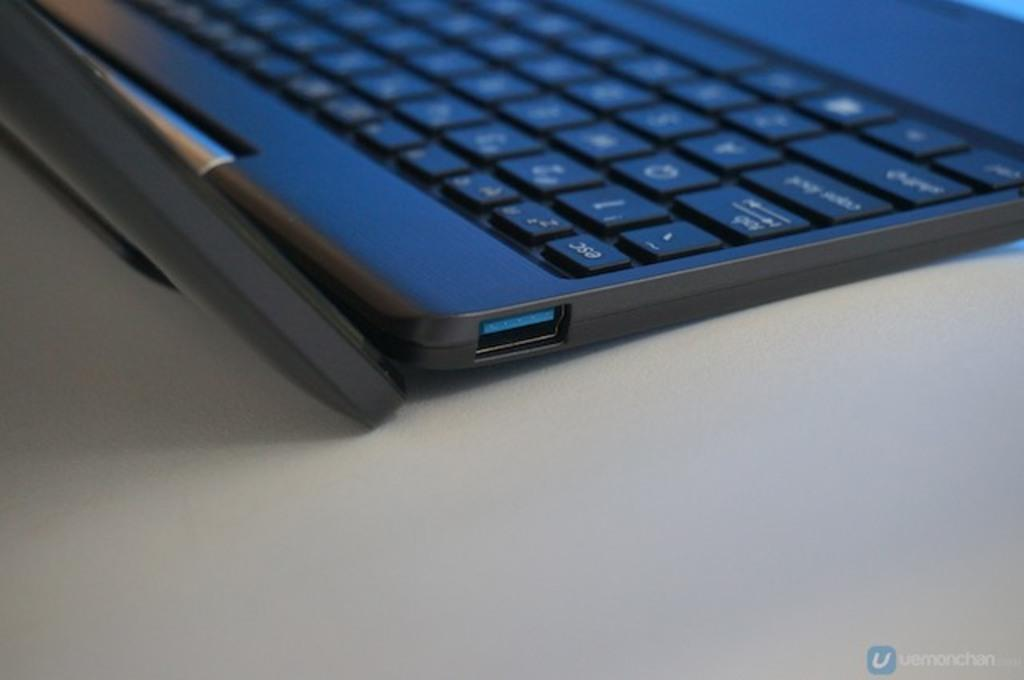<image>
Give a short and clear explanation of the subsequent image. A uemonchan photo of the corner of an open laptop 